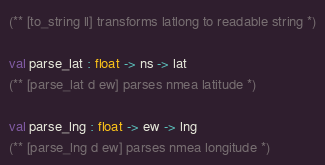Convert code to text. <code><loc_0><loc_0><loc_500><loc_500><_OCaml_>(** [to_string ll] transforms latlong to readable string *)

val parse_lat : float -> ns -> lat
(** [parse_lat d ew] parses nmea latitude *)

val parse_lng : float -> ew -> lng
(** [parse_lng d ew] parses nmea longitude *)</code> 